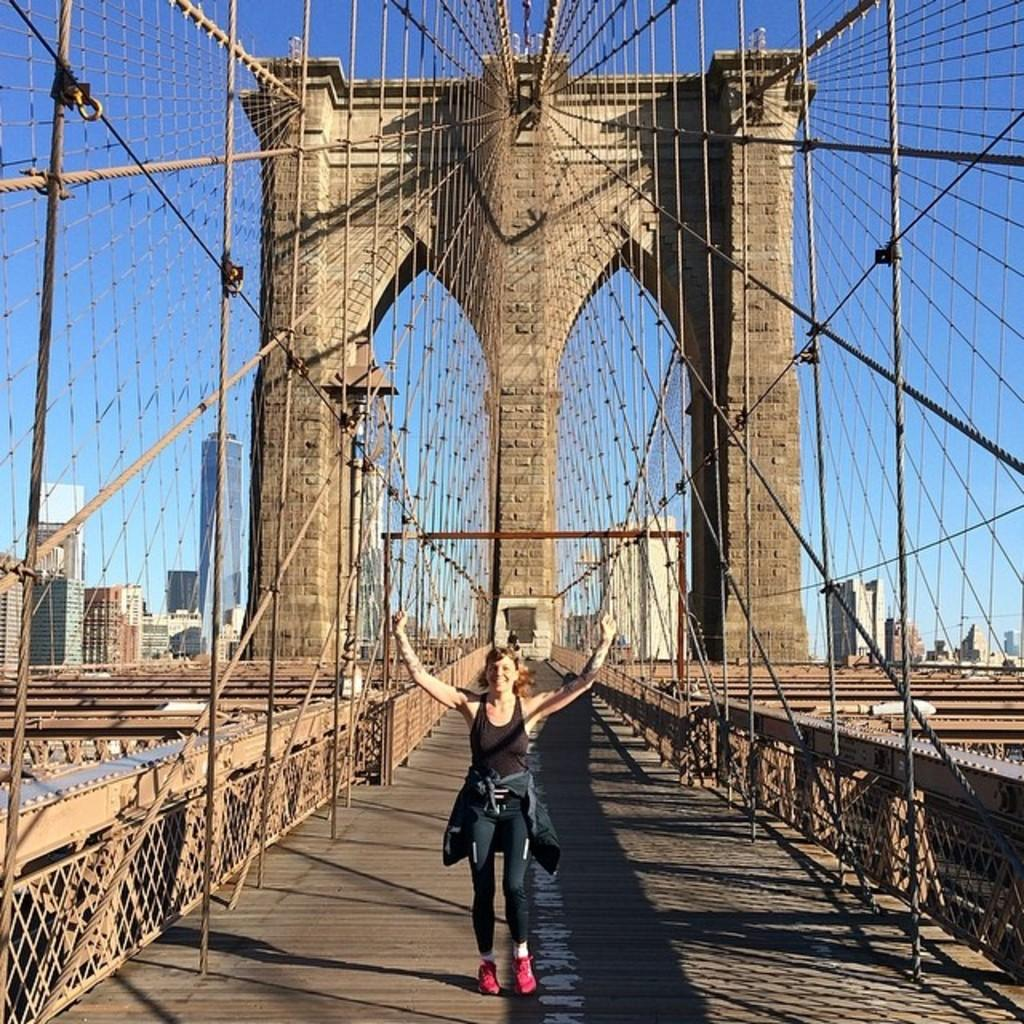Who is present in the image? There is a woman in the image. What is the woman wearing? The woman is wearing a black dress and red shoes. Where is the woman located in the image? The woman is standing on a bridge. What can be seen in the background of the image? There are buildings and the sky visible in the background of the image. What else is present in the image? There are ropes visible in the image. What type of war is depicted in the image? There is no war depicted in the image; it features a woman standing on a bridge. Are there any police officers or crooks present in the image? There are no police officers or crooks present in the image. 